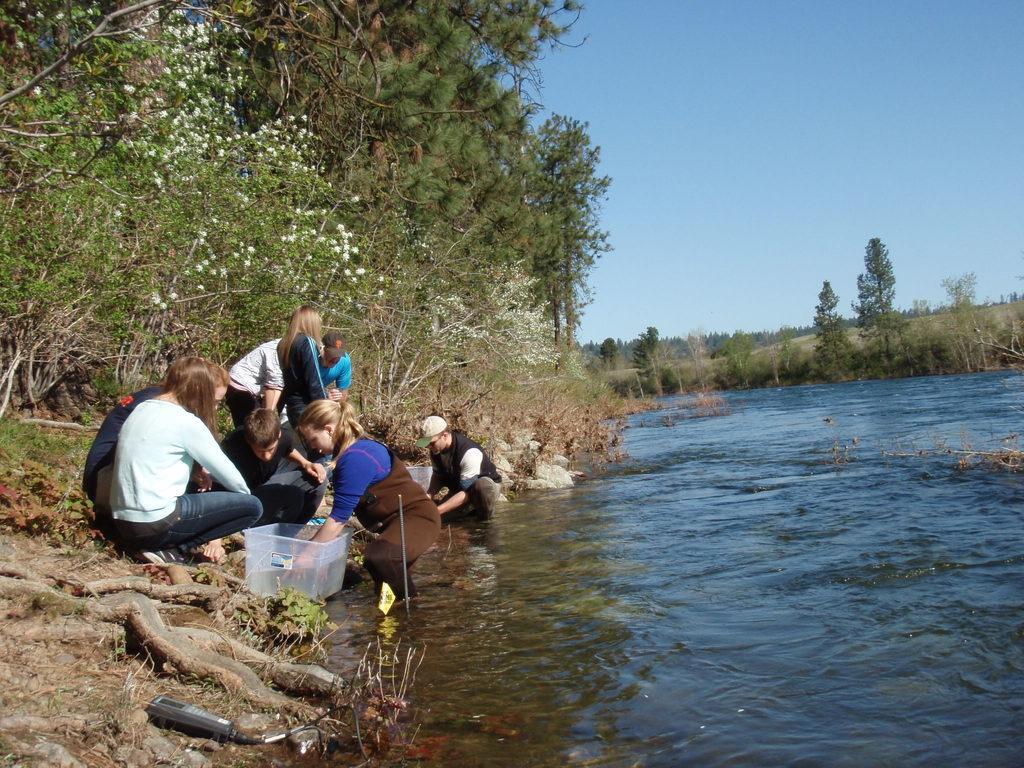Could you give a brief overview of what you see in this image? Here we can see people, container and water. Background we can see plants,trees and sky. 